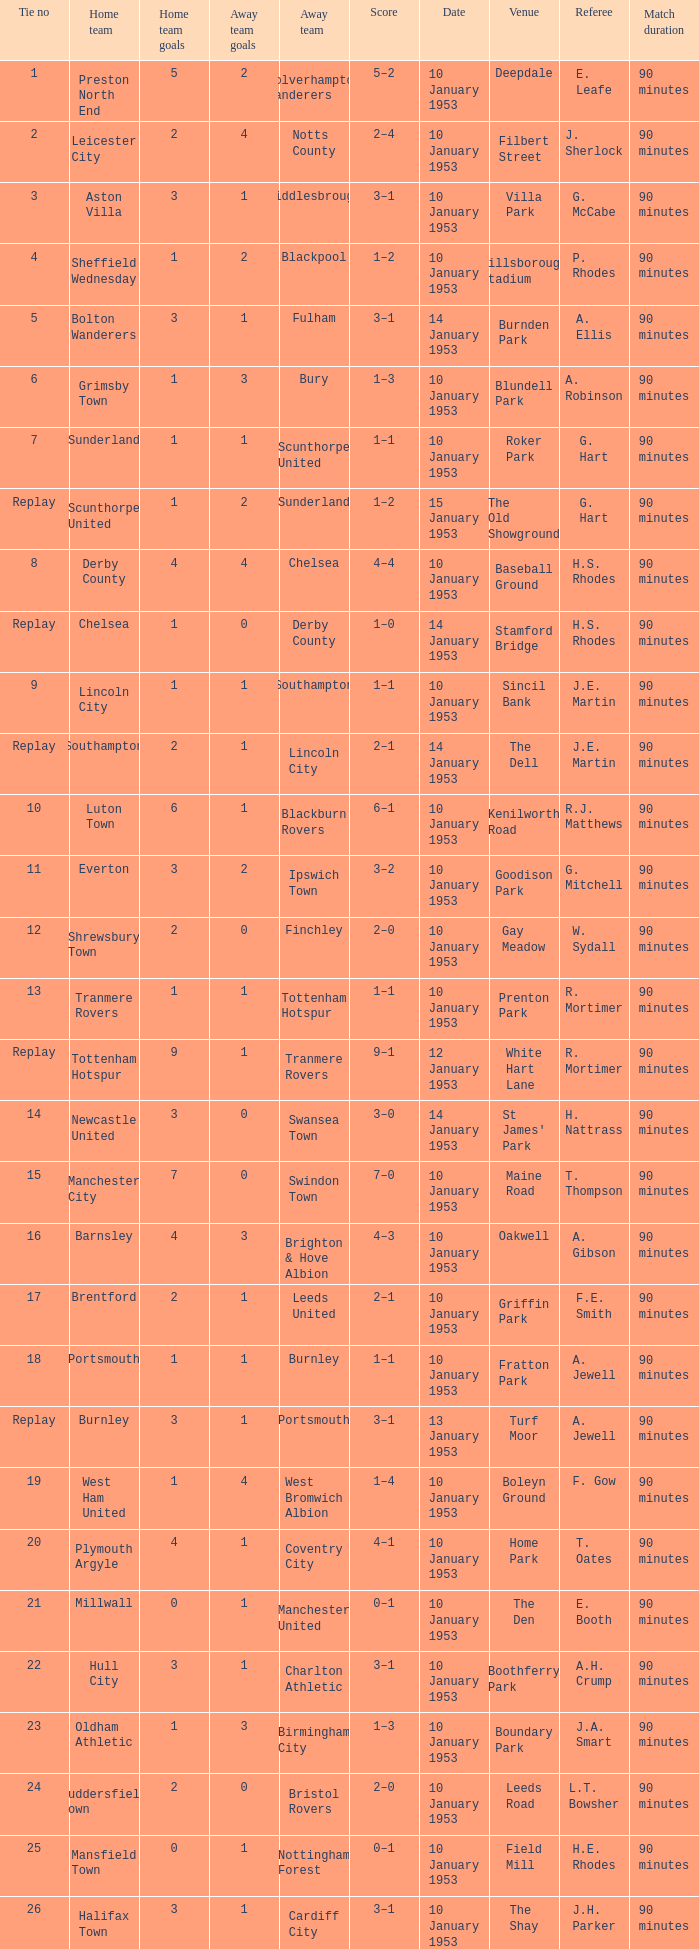Can you parse all the data within this table? {'header': ['Tie no', 'Home team', 'Home team goals', 'Away team goals', 'Away team', 'Score', 'Date', 'Venue', 'Referee', 'Match duration'], 'rows': [['1', 'Preston North End', '5', '2', 'Wolverhampton Wanderers', '5–2', '10 January 1953', 'Deepdale', 'E. Leafe', '90 minutes'], ['2', 'Leicester City', '2', '4', 'Notts County', '2–4', '10 January 1953', 'Filbert Street', 'J. Sherlock', '90 minutes'], ['3', 'Aston Villa', '3', '1', 'Middlesbrough', '3–1', '10 January 1953', 'Villa Park', 'G. McCabe', '90 minutes'], ['4', 'Sheffield Wednesday', '1', '2', 'Blackpool', '1–2', '10 January 1953', 'Hillsborough Stadium', 'P. Rhodes', '90 minutes'], ['5', 'Bolton Wanderers', '3', '1', 'Fulham', '3–1', '14 January 1953', 'Burnden Park', 'A. Ellis', '90 minutes'], ['6', 'Grimsby Town', '1', '3', 'Bury', '1–3', '10 January 1953', 'Blundell Park', 'A. Robinson', '90 minutes'], ['7', 'Sunderland', '1', '1', 'Scunthorpe United', '1–1', '10 January 1953', 'Roker Park', 'G. Hart', '90 minutes'], ['Replay', 'Scunthorpe United', '1', '2', 'Sunderland', '1–2', '15 January 1953', 'The Old Showground', 'G. Hart', '90 minutes'], ['8', 'Derby County', '4', '4', 'Chelsea', '4–4', '10 January 1953', 'Baseball Ground', 'H.S. Rhodes', '90 minutes'], ['Replay', 'Chelsea', '1', '0', 'Derby County', '1–0', '14 January 1953', 'Stamford Bridge', 'H.S. Rhodes', '90 minutes'], ['9', 'Lincoln City', '1', '1', 'Southampton', '1–1', '10 January 1953', 'Sincil Bank', 'J.E. Martin', '90 minutes'], ['Replay', 'Southampton', '2', '1', 'Lincoln City', '2–1', '14 January 1953', 'The Dell', 'J.E. Martin', '90 minutes'], ['10', 'Luton Town', '6', '1', 'Blackburn Rovers', '6–1', '10 January 1953', 'Kenilworth Road', 'R.J. Matthews', '90 minutes'], ['11', 'Everton', '3', '2', 'Ipswich Town', '3–2', '10 January 1953', 'Goodison Park', 'G. Mitchell', '90 minutes'], ['12', 'Shrewsbury Town', '2', '0', 'Finchley', '2–0', '10 January 1953', 'Gay Meadow', 'W. Sydall', '90 minutes'], ['13', 'Tranmere Rovers', '1', '1', 'Tottenham Hotspur', '1–1', '10 January 1953', 'Prenton Park', 'R. Mortimer', '90 minutes'], ['Replay', 'Tottenham Hotspur', '9', '1', 'Tranmere Rovers', '9–1', '12 January 1953', 'White Hart Lane', 'R. Mortimer', '90 minutes'], ['14', 'Newcastle United', '3', '0', 'Swansea Town', '3–0', '14 January 1953', "St James' Park", 'H. Nattrass', '90 minutes'], ['15', 'Manchester City', '7', '0', 'Swindon Town', '7–0', '10 January 1953', 'Maine Road', 'T. Thompson', '90 minutes'], ['16', 'Barnsley', '4', '3', 'Brighton & Hove Albion', '4–3', '10 January 1953', 'Oakwell', 'A. Gibson', '90 minutes'], ['17', 'Brentford', '2', '1', 'Leeds United', '2–1', '10 January 1953', 'Griffin Park', 'F.E. Smith', '90 minutes'], ['18', 'Portsmouth', '1', '1', 'Burnley', '1–1', '10 January 1953', 'Fratton Park', 'A. Jewell', '90 minutes'], ['Replay', 'Burnley', '3', '1', 'Portsmouth', '3–1', '13 January 1953', 'Turf Moor', 'A. Jewell', '90 minutes'], ['19', 'West Ham United', '1', '4', 'West Bromwich Albion', '1–4', '10 January 1953', 'Boleyn Ground', 'F. Gow', '90 minutes'], ['20', 'Plymouth Argyle', '4', '1', 'Coventry City', '4–1', '10 January 1953', 'Home Park', 'T. Oates', '90 minutes'], ['21', 'Millwall', '0', '1', 'Manchester United', '0–1', '10 January 1953', 'The Den', 'E. Booth', '90 minutes'], ['22', 'Hull City', '3', '1', 'Charlton Athletic', '3–1', '10 January 1953', 'Boothferry Park', 'A.H. Crump', '90 minutes'], ['23', 'Oldham Athletic', '1', '3', 'Birmingham City', '1–3', '10 January 1953', 'Boundary Park', 'J.A. Smart', '90 minutes'], ['24', 'Huddersfield Town', '2', '0', 'Bristol Rovers', '2–0', '10 January 1953', 'Leeds Road', 'L.T. Bowsher', '90 minutes'], ['25', 'Mansfield Town', '0', '1', 'Nottingham Forest', '0–1', '10 January 1953', 'Field Mill', 'H.E. Rhodes', '90 minutes'], ['26', 'Halifax Town', '3', '1', 'Cardiff City', '3–1', '10 January 1953', 'The Shay', 'J.H. Parker', '90 minutes'], ['27', 'Newport County', '1', '4', 'Sheffield United', '1–4', '10 January 1953', 'Somerton Park', 'G. Lloyd', '90 minutes'], ['28', 'Arsenal', '4', '0', 'Doncaster Rovers', '4–0', '10 January 1953', 'Highbury', 'A.E. Ellis', '90 minutes'], ['29', 'Walthamstow Avenue', '2', '1', 'Stockport County', '2–1', '10 January 1953', 'Wadham Lodge Stadium', 'H.G. Reader', '90 minutes'], ['30', 'Stoke City', '2', '1', 'Wrexham', '2–1', '10 January 1953', 'Victoria Ground', 'A.E. Leafe', '90 minutes'], ['31', 'Rotherham United', '2', '2', 'Colchester United', '2–2', '10 January 1953', 'Millmoor', 'A.C. Thompson', '90 minutes'], ['Replay', 'Colchester United', '0', '2', 'Rotherham United', '0–2', '15 January 1953', 'Layer Road', 'A.C. Thompson', '90 minutes'], ['32', 'Gateshead', '1', '0', 'Liverpool', '1–0', '10 January 1953', 'Redheugh Park', 'A.W. Smith', '90 minutes']]} What score has charlton athletic as the away team? 3–1. 